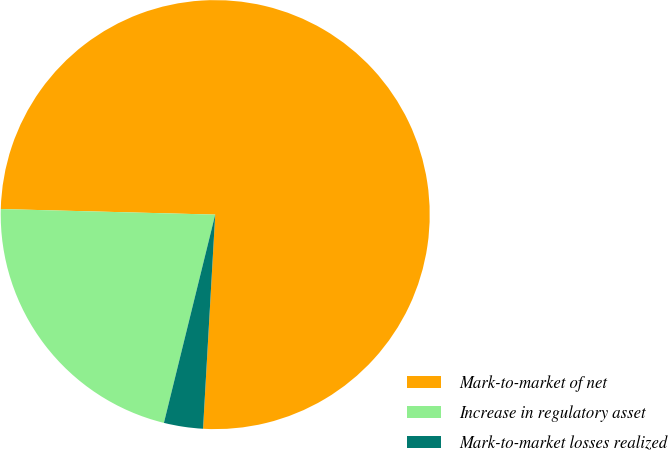<chart> <loc_0><loc_0><loc_500><loc_500><pie_chart><fcel>Mark-to-market of net<fcel>Increase in regulatory asset<fcel>Mark-to-market losses realized<nl><fcel>75.49%<fcel>21.57%<fcel>2.94%<nl></chart> 